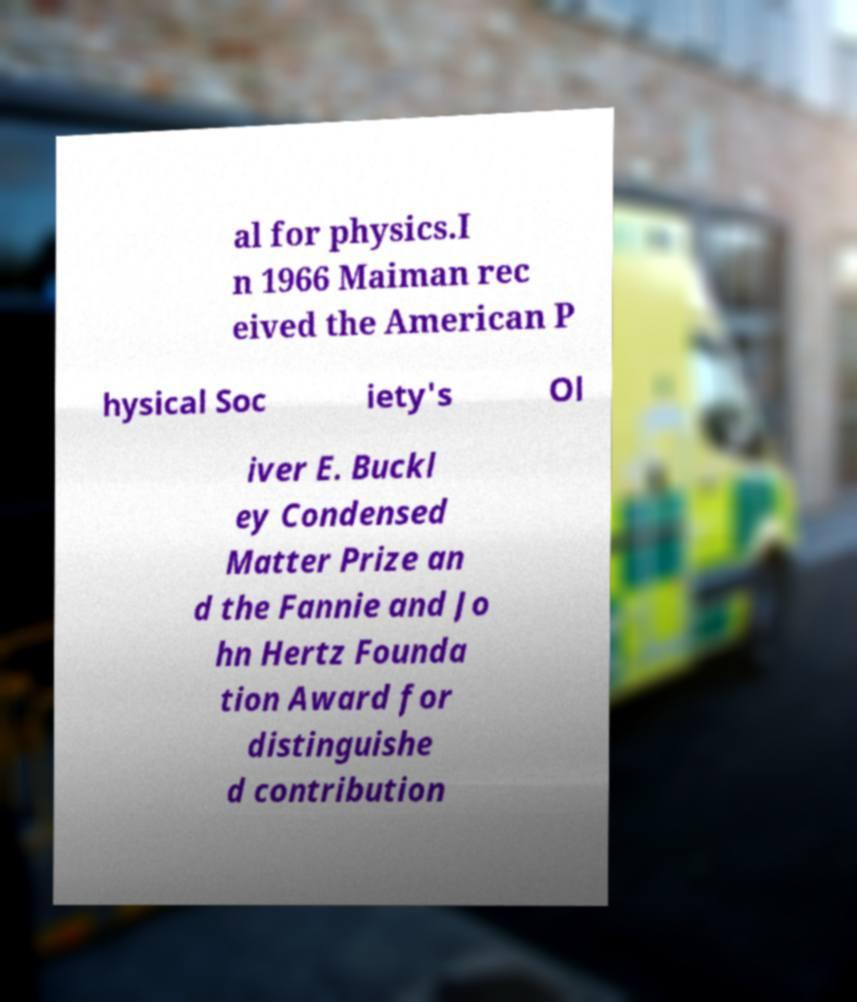Please identify and transcribe the text found in this image. al for physics.I n 1966 Maiman rec eived the American P hysical Soc iety's Ol iver E. Buckl ey Condensed Matter Prize an d the Fannie and Jo hn Hertz Founda tion Award for distinguishe d contribution 